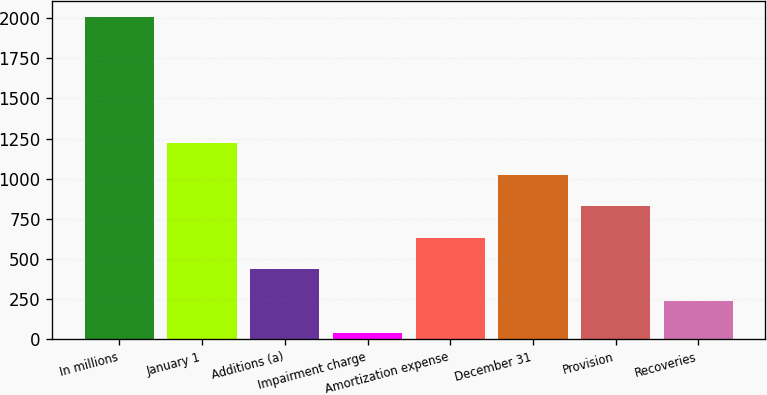<chart> <loc_0><loc_0><loc_500><loc_500><bar_chart><fcel>In millions<fcel>January 1<fcel>Additions (a)<fcel>Impairment charge<fcel>Amortization expense<fcel>December 31<fcel>Provision<fcel>Recoveries<nl><fcel>2010<fcel>1222<fcel>434<fcel>40<fcel>631<fcel>1025<fcel>828<fcel>237<nl></chart> 